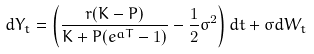<formula> <loc_0><loc_0><loc_500><loc_500>d Y _ { t } = \left ( \frac { r ( K - P ) } { K + P ( e ^ { a T } - 1 ) } - \frac { 1 } { 2 } \sigma ^ { 2 } \right ) d t + \sigma d W _ { t }</formula> 